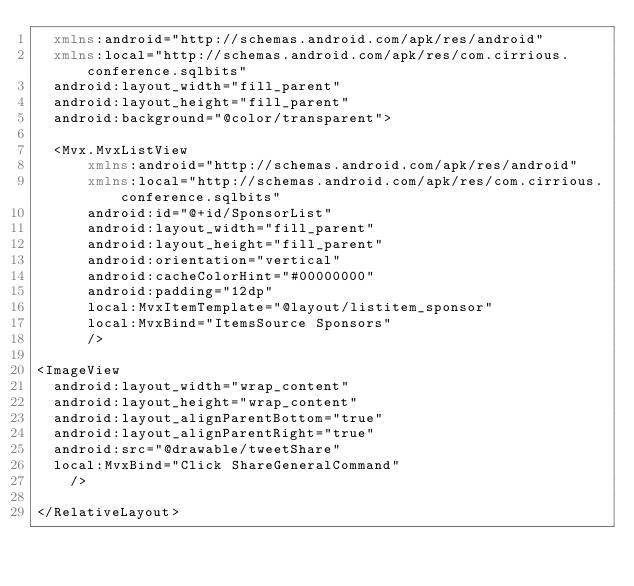<code> <loc_0><loc_0><loc_500><loc_500><_XML_>  xmlns:android="http://schemas.android.com/apk/res/android"
  xmlns:local="http://schemas.android.com/apk/res/com.cirrious.conference.sqlbits"
  android:layout_width="fill_parent"
  android:layout_height="fill_parent"
  android:background="@color/transparent">
  
  <Mvx.MvxListView
      xmlns:android="http://schemas.android.com/apk/res/android"
      xmlns:local="http://schemas.android.com/apk/res/com.cirrious.conference.sqlbits"
      android:id="@+id/SponsorList"
      android:layout_width="fill_parent"
      android:layout_height="fill_parent"
      android:orientation="vertical"
      android:cacheColorHint="#00000000" 
      android:padding="12dp"
      local:MvxItemTemplate="@layout/listitem_sponsor"
      local:MvxBind="ItemsSource Sponsors"
      />

<ImageView
  android:layout_width="wrap_content"
  android:layout_height="wrap_content"
  android:layout_alignParentBottom="true"
  android:layout_alignParentRight="true"
  android:src="@drawable/tweetShare"
  local:MvxBind="Click ShareGeneralCommand"
    />

</RelativeLayout></code> 